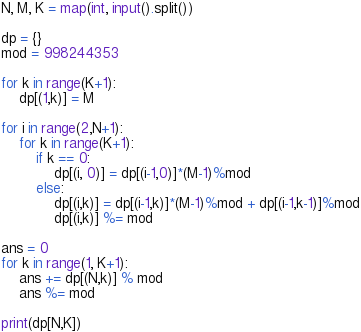Convert code to text. <code><loc_0><loc_0><loc_500><loc_500><_Python_>N, M, K = map(int, input().split())

dp = {}
mod = 998244353

for k in range(K+1):
    dp[(1,k)] = M

for i in range(2,N+1):
    for k in range(K+1):
        if k == 0:
            dp[(i, 0)] = dp[(i-1,0)]*(M-1)%mod
        else:
            dp[(i,k)] = dp[(i-1,k)]*(M-1)%mod + dp[(i-1,k-1)]%mod
            dp[(i,k)] %= mod

ans = 0
for k in range(1, K+1):
    ans += dp[(N,k)] % mod
    ans %= mod

print(dp[N,K])</code> 